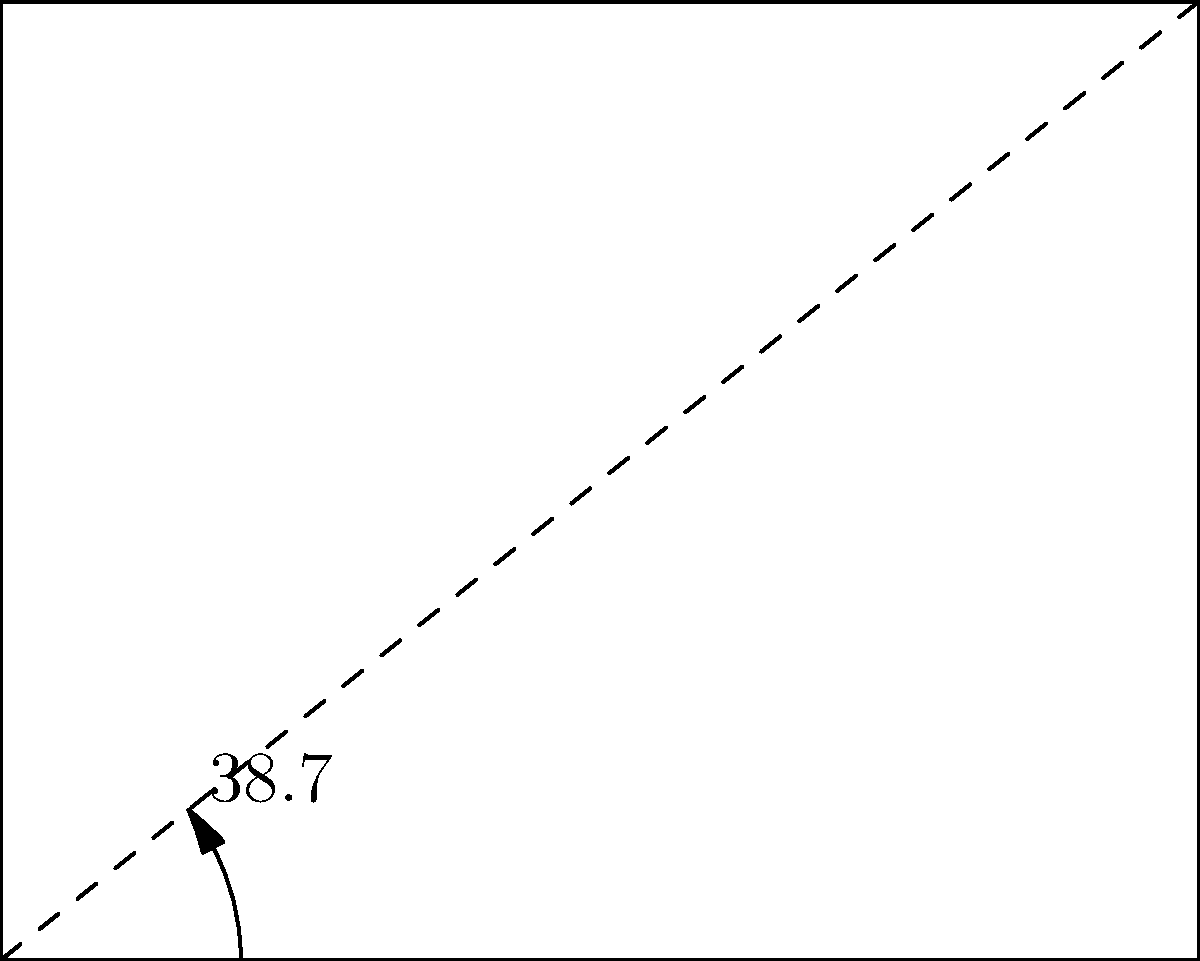In your hospital bed, you've been adjusting the angle for comfort. The bed's backrest forms a 38.7° angle with the horizontal base. If the bed frame forms a rectangle when fully flat, what is the complement of the backrest angle? To solve this problem, let's follow these steps:

1) First, recall that complementary angles are two angles that add up to 90°.

2) In this case, we're given that the backrest angle is 38.7°.

3) To find its complement, we need to subtract this angle from 90°:

   $$90° - 38.7° = 51.3°$$

4) We can verify this by looking at the diagram:
   - The right angle at point A is 90°
   - The angle formed by the backrest is 38.7°
   - The remaining angle must be 51.3° to sum to 90°

5) This 51.3° angle represents the complement of the backrest angle.
Answer: 51.3° 